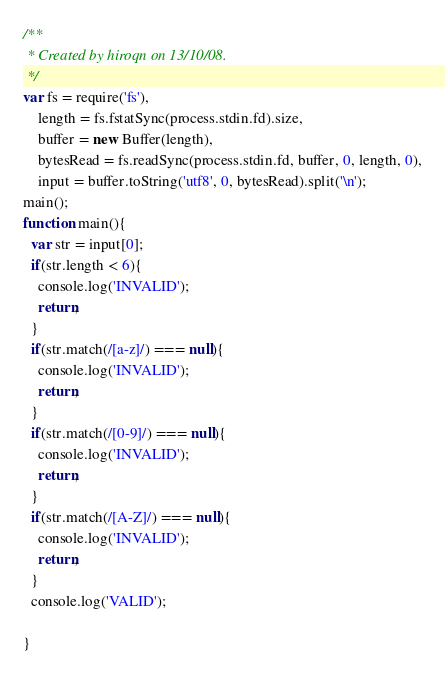<code> <loc_0><loc_0><loc_500><loc_500><_JavaScript_>/**
 * Created by hiroqn on 13/10/08.
 */
var fs = require('fs'),
    length = fs.fstatSync(process.stdin.fd).size,
    buffer = new Buffer(length),
    bytesRead = fs.readSync(process.stdin.fd, buffer, 0, length, 0),
    input = buffer.toString('utf8', 0, bytesRead).split('\n');
main();
function main(){
  var str = input[0];
  if(str.length < 6){
    console.log('INVALID');
    return;
  }
  if(str.match(/[a-z]/) === null){
    console.log('INVALID');
    return;
  }
  if(str.match(/[0-9]/) === null){
    console.log('INVALID');
    return;
  }
  if(str.match(/[A-Z]/) === null){
    console.log('INVALID');
    return;
  }
  console.log('VALID');

}</code> 